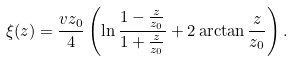Convert formula to latex. <formula><loc_0><loc_0><loc_500><loc_500>\xi ( z ) = \frac { v z _ { 0 } } { 4 } \left ( \ln \frac { 1 - \frac { z } { z _ { 0 } } } { 1 + \frac { z } { z _ { 0 } } } + 2 \arctan \frac { z } { z _ { 0 } } \right ) .</formula> 